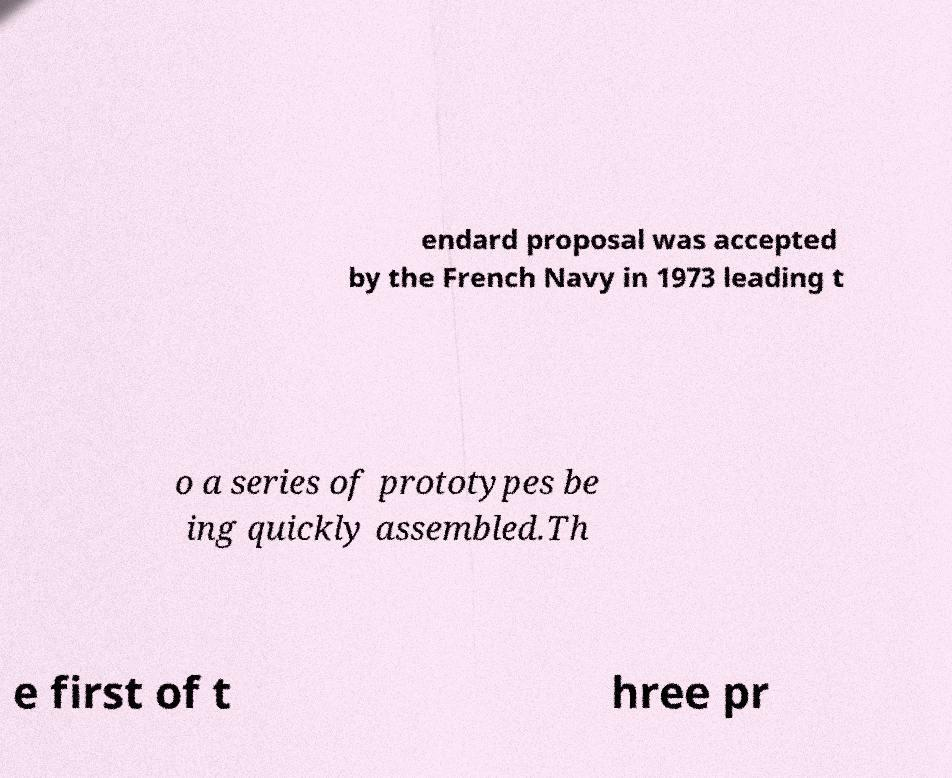For documentation purposes, I need the text within this image transcribed. Could you provide that? endard proposal was accepted by the French Navy in 1973 leading t o a series of prototypes be ing quickly assembled.Th e first of t hree pr 